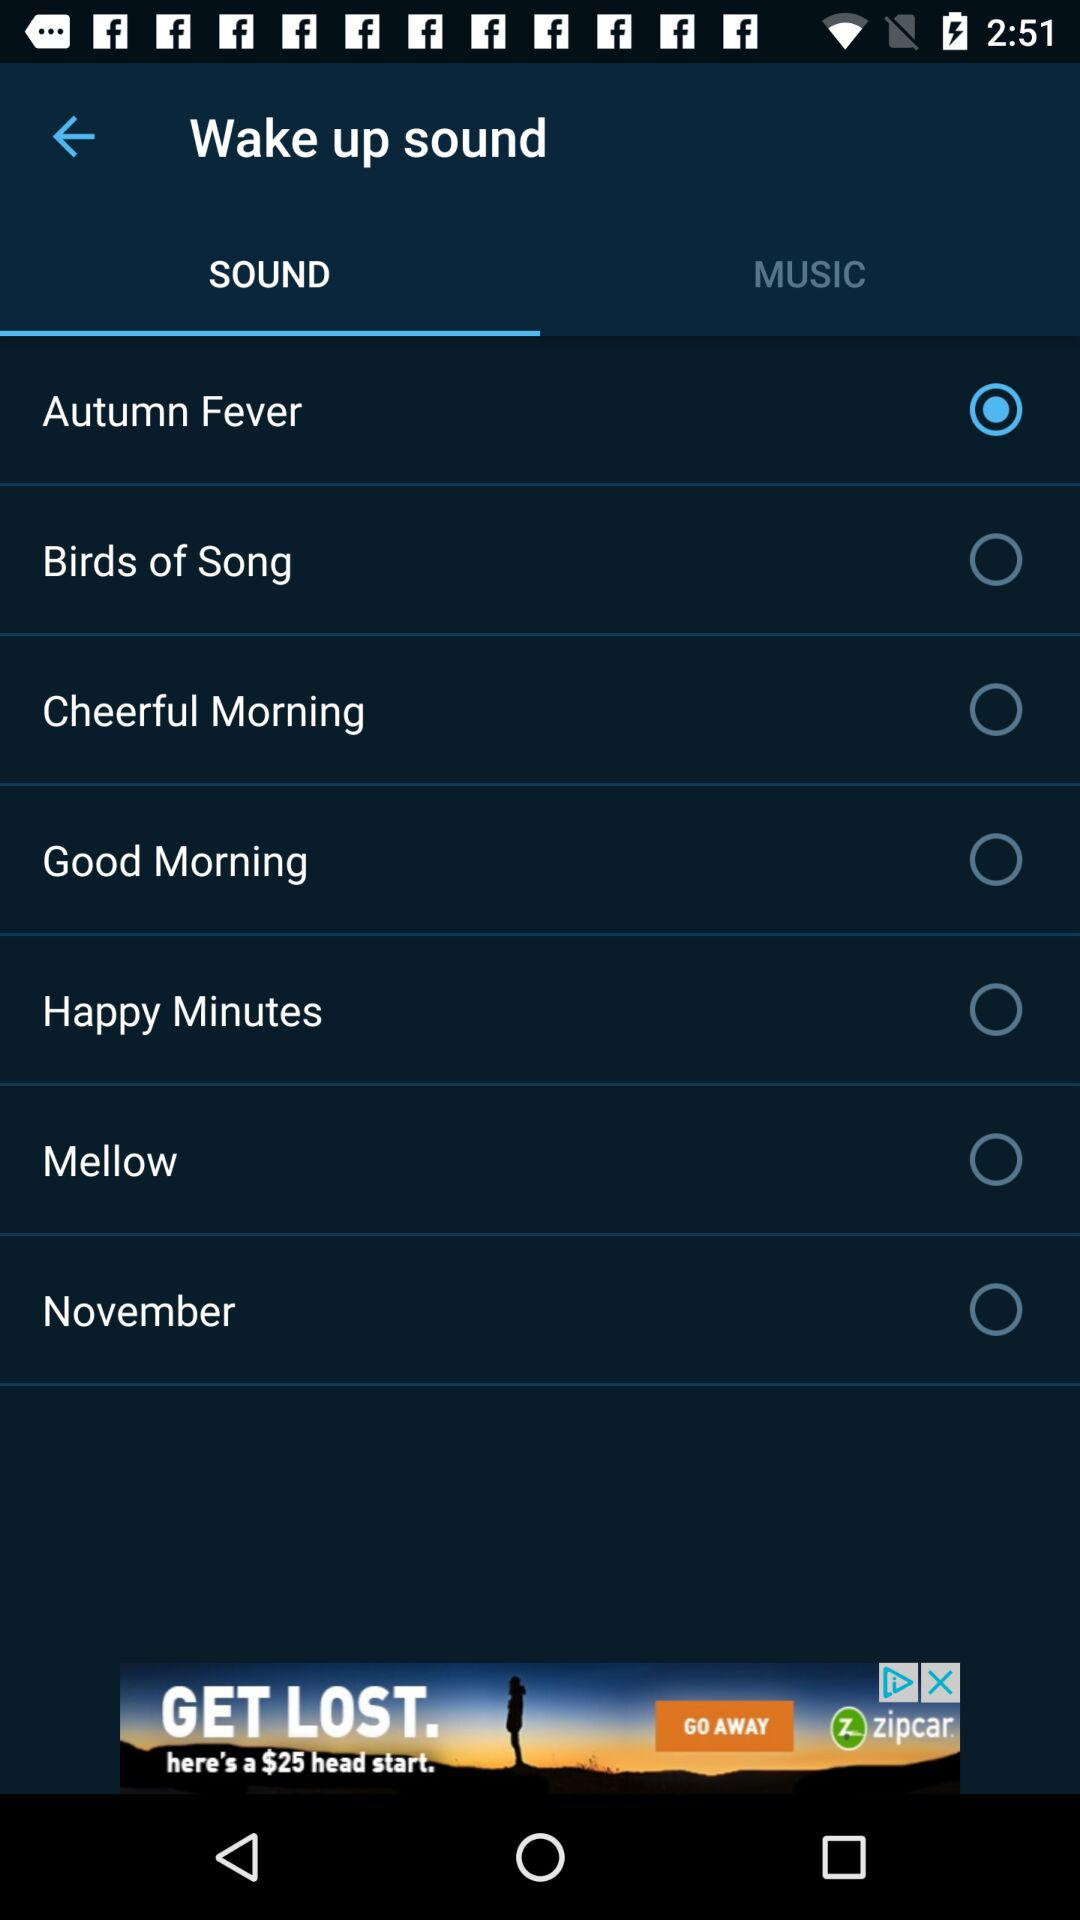Is "Mellow" selected or not? "Mellow" is not selected. 